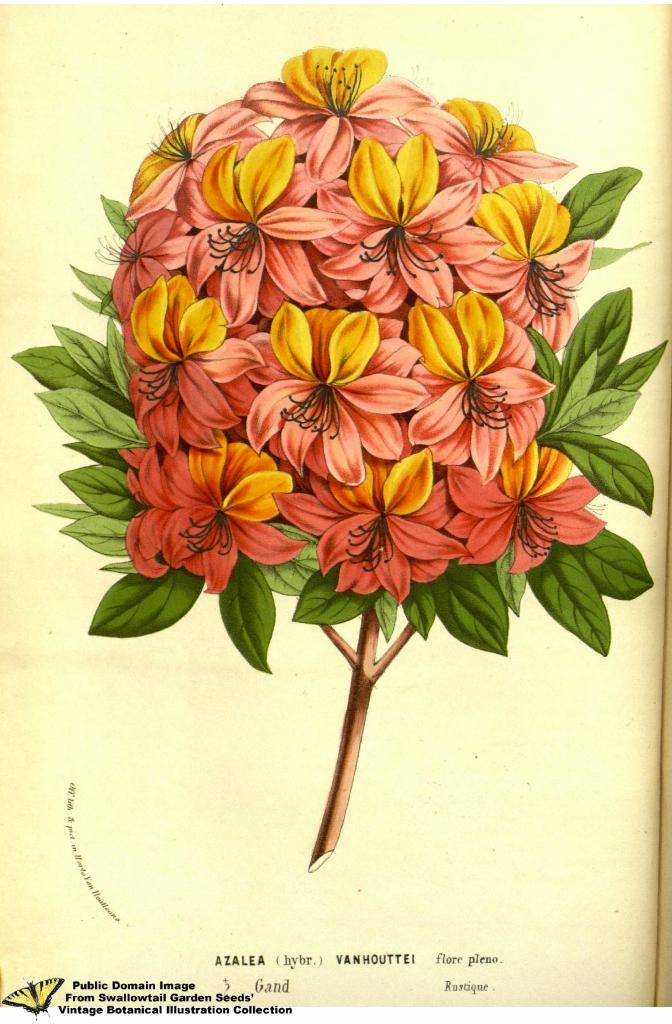What is the main subject of the image? The main subject of the image is a bunch of flowers. Can you describe the flowers in the image? The flowers have leaves. What type of crow is sitting on the tail of the wood in the image? There is no crow or wood present in the image; it only features a bunch of flowers with leaves. 